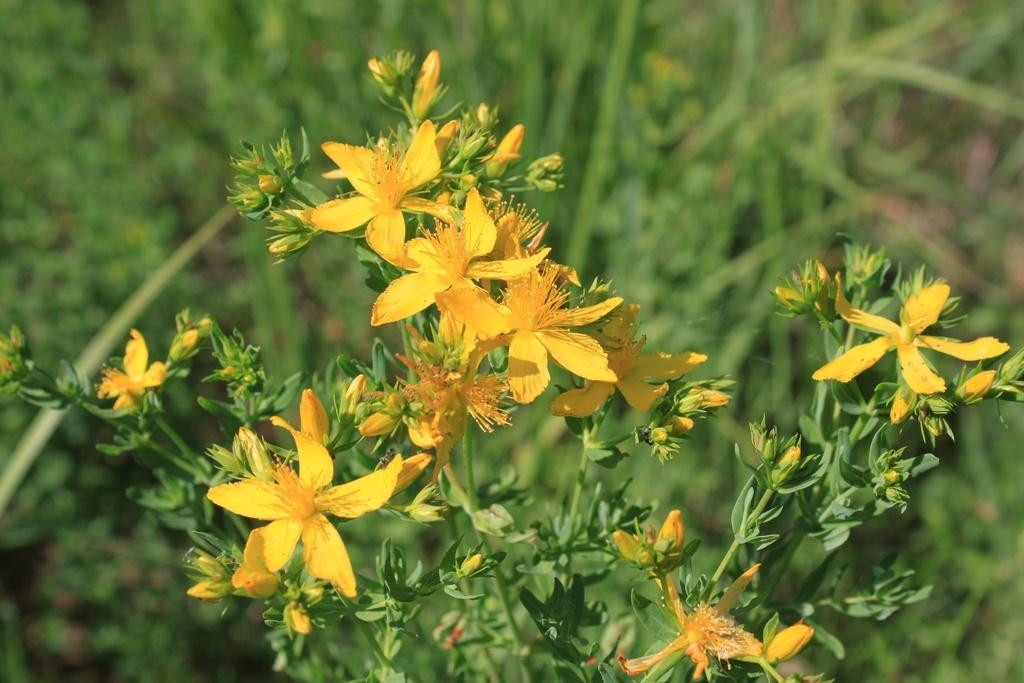What type of living organism is present in the image? There is a plant in the image. What specific feature of the plant can be observed? The plant has flowers. What color are the flowers on the plant? The flowers are yellow. Are there any other plants visible in the image? Yes, there are other plants visible in the image. Where is the nest located in the image? There is no nest present in the image. What type of health issues can be seen affecting the plant in the image? There are no health issues visible on the plant in the image. 